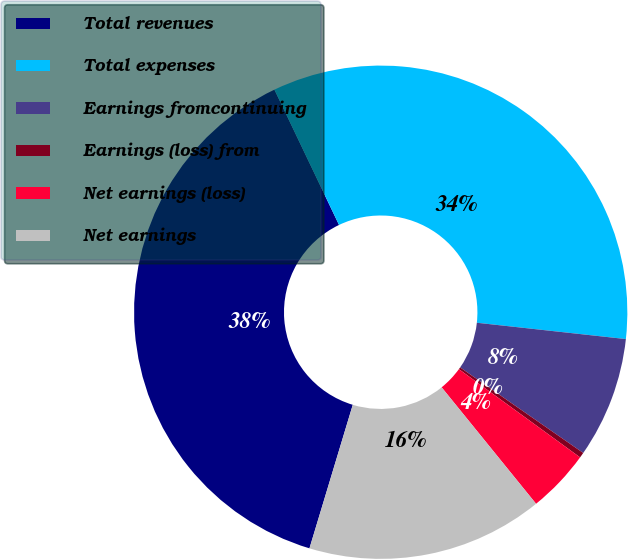Convert chart to OTSL. <chart><loc_0><loc_0><loc_500><loc_500><pie_chart><fcel>Total revenues<fcel>Total expenses<fcel>Earnings fromcontinuing<fcel>Earnings (loss) from<fcel>Net earnings (loss)<fcel>Net earnings<nl><fcel>38.25%<fcel>33.83%<fcel>7.93%<fcel>0.35%<fcel>4.14%<fcel>15.51%<nl></chart> 